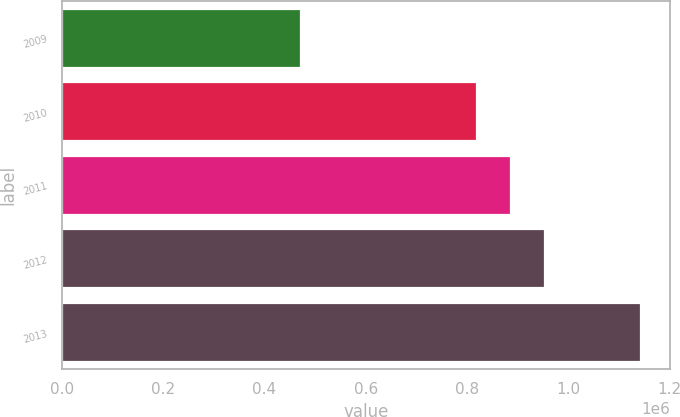<chart> <loc_0><loc_0><loc_500><loc_500><bar_chart><fcel>2009<fcel>2010<fcel>2011<fcel>2012<fcel>2013<nl><fcel>471893<fcel>820701<fcel>887988<fcel>955276<fcel>1.14477e+06<nl></chart> 